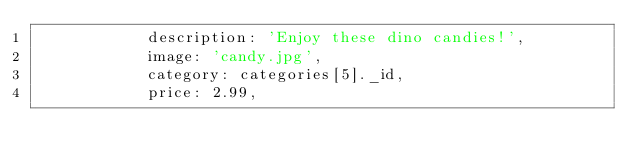<code> <loc_0><loc_0><loc_500><loc_500><_JavaScript_>            description: 'Enjoy these dino candies!',
            image: 'candy.jpg',
            category: categories[5]._id,
            price: 2.99,</code> 